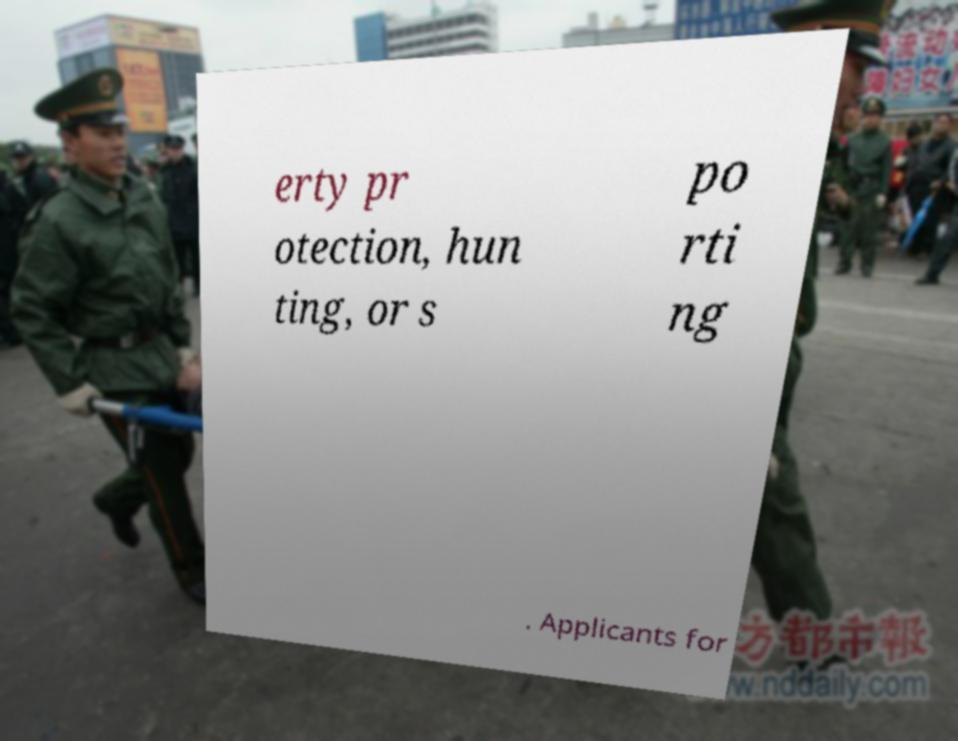Can you accurately transcribe the text from the provided image for me? erty pr otection, hun ting, or s po rti ng . Applicants for 